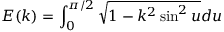<formula> <loc_0><loc_0><loc_500><loc_500>E ( k ) = \int _ { 0 } ^ { \pi / 2 } \sqrt { 1 - k ^ { 2 } \sin ^ { 2 } u } d u</formula> 